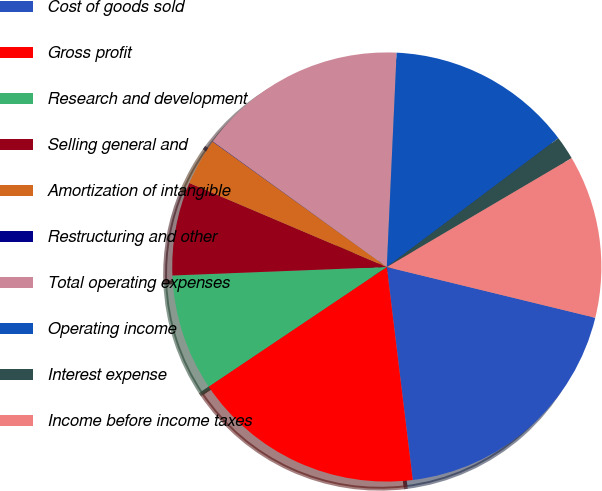Convert chart to OTSL. <chart><loc_0><loc_0><loc_500><loc_500><pie_chart><fcel>Cost of goods sold<fcel>Gross profit<fcel>Research and development<fcel>Selling general and<fcel>Amortization of intangible<fcel>Restructuring and other<fcel>Total operating expenses<fcel>Operating income<fcel>Interest expense<fcel>Income before income taxes<nl><fcel>19.27%<fcel>17.52%<fcel>8.78%<fcel>7.03%<fcel>3.53%<fcel>0.03%<fcel>15.77%<fcel>14.02%<fcel>1.78%<fcel>12.27%<nl></chart> 